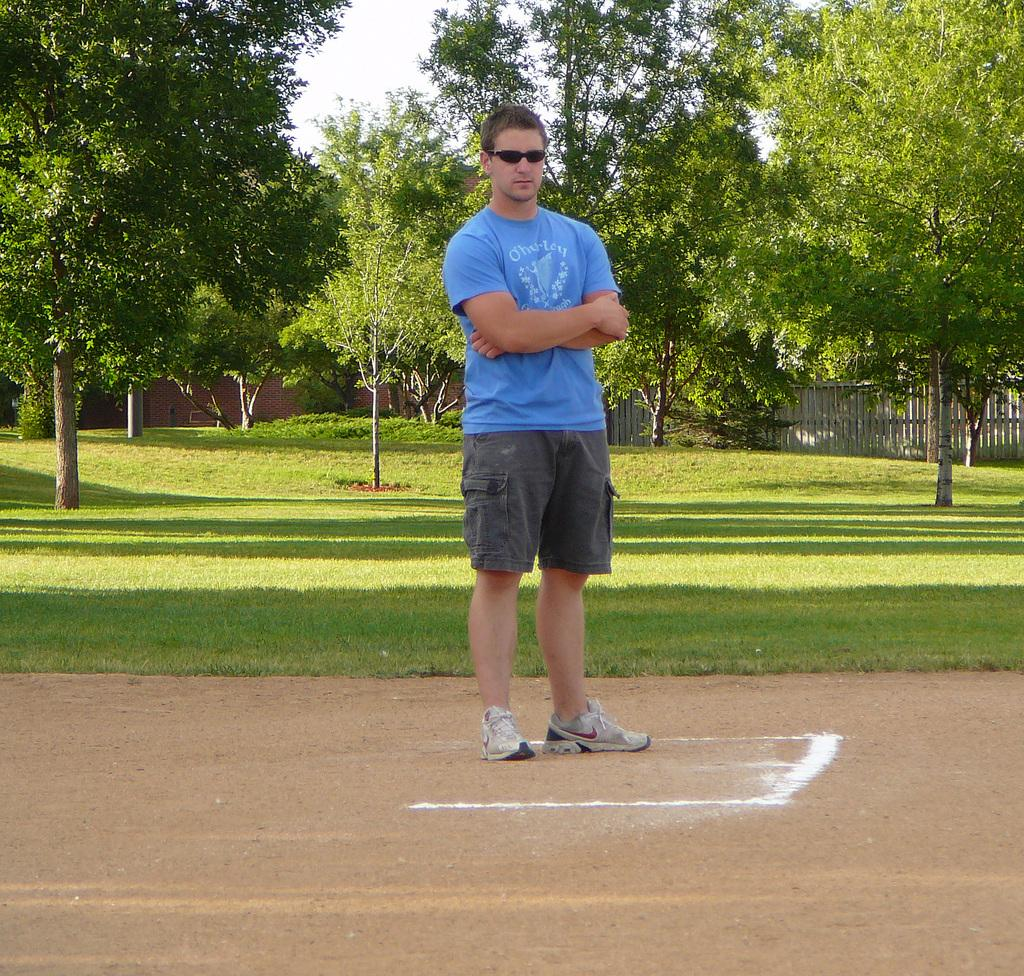What is the main subject of the image? There is a man standing in the image. Where is the man standing? The man is standing on the ground. What can be seen behind the man? There is a garden behind the man. What features are present in the garden? There are many trees in the garden, and there is a fence around the garden. What type of shoes is the kitten wearing in the image? There is no kitten present in the image, and therefore no shoes to describe. 